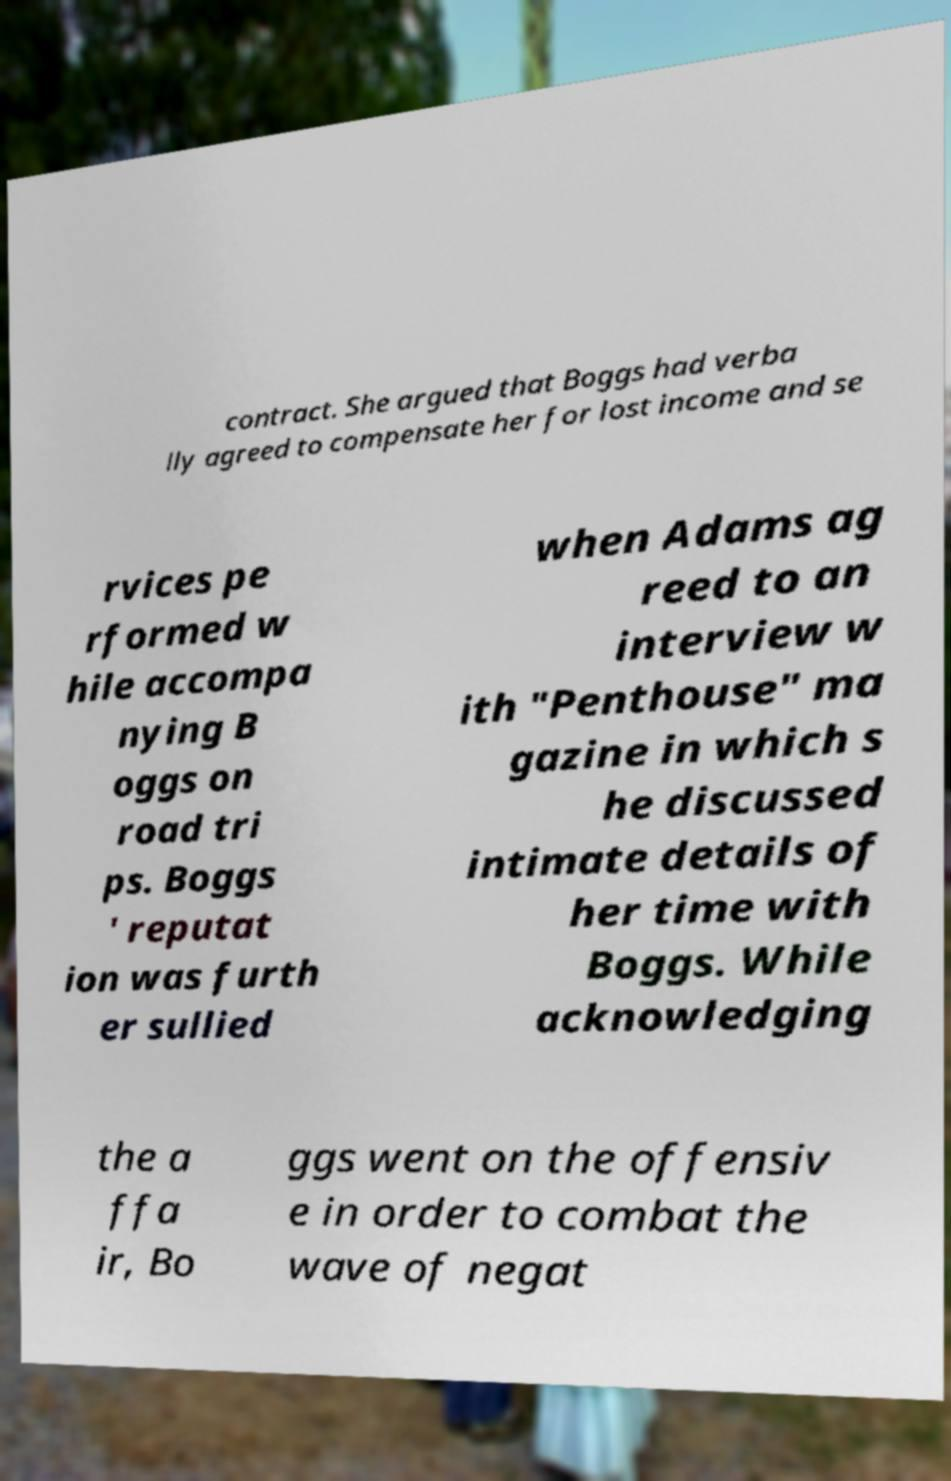Can you accurately transcribe the text from the provided image for me? contract. She argued that Boggs had verba lly agreed to compensate her for lost income and se rvices pe rformed w hile accompa nying B oggs on road tri ps. Boggs ' reputat ion was furth er sullied when Adams ag reed to an interview w ith "Penthouse" ma gazine in which s he discussed intimate details of her time with Boggs. While acknowledging the a ffa ir, Bo ggs went on the offensiv e in order to combat the wave of negat 